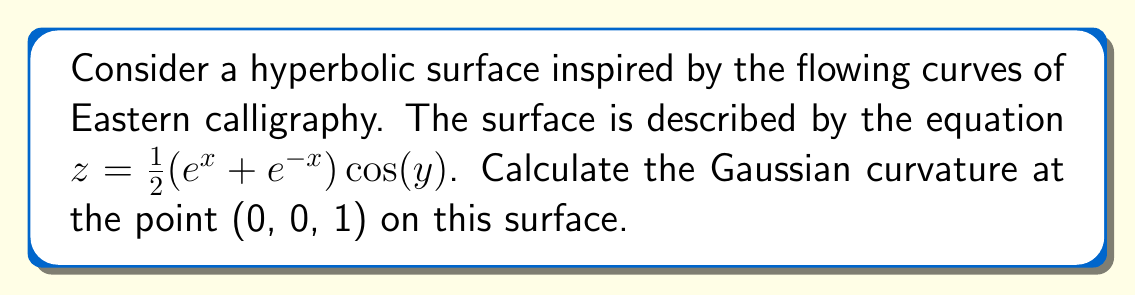Could you help me with this problem? To calculate the Gaussian curvature of the hyperbolic surface, we'll follow these steps:

1) The Gaussian curvature K is given by $K = \frac{LN - M^2}{EG - F^2}$, where E, F, G are the coefficients of the first fundamental form, and L, M, N are the coefficients of the second fundamental form.

2) First, we need to calculate the partial derivatives:
   $z_x = \frac{1}{2}(e^x - e^{-x}) \cos(y)$
   $z_y = -\frac{1}{2}(e^x + e^{-x}) \sin(y)$
   $z_{xx} = \frac{1}{2}(e^x + e^{-x}) \cos(y)$
   $z_{xy} = -\frac{1}{2}(e^x - e^{-x}) \sin(y)$
   $z_{yy} = -\frac{1}{2}(e^x + e^{-x}) \cos(y)$

3) At the point (0, 0, 1):
   $z_x = 0$, $z_y = 0$, $z_{xx} = 1$, $z_{xy} = 0$, $z_{yy} = -1$

4) Calculate E, F, G:
   $E = 1 + z_x^2 = 1$
   $F = z_x z_y = 0$
   $G = 1 + z_y^2 = 1$

5) Calculate L, M, N:
   $L = \frac{z_{xx}}{\sqrt{1 + z_x^2 + z_y^2}} = \frac{1}{\sqrt{1}} = 1$
   $M = \frac{z_{xy}}{\sqrt{1 + z_x^2 + z_y^2}} = 0$
   $N = \frac{z_{yy}}{\sqrt{1 + z_x^2 + z_y^2}} = -1$

6) Now we can calculate the Gaussian curvature:
   $K = \frac{LN - M^2}{EG - F^2} = \frac{(1)(-1) - 0^2}{(1)(1) - 0^2} = -1$

Therefore, the Gaussian curvature at the point (0, 0, 1) is -1.
Answer: $K = -1$ 